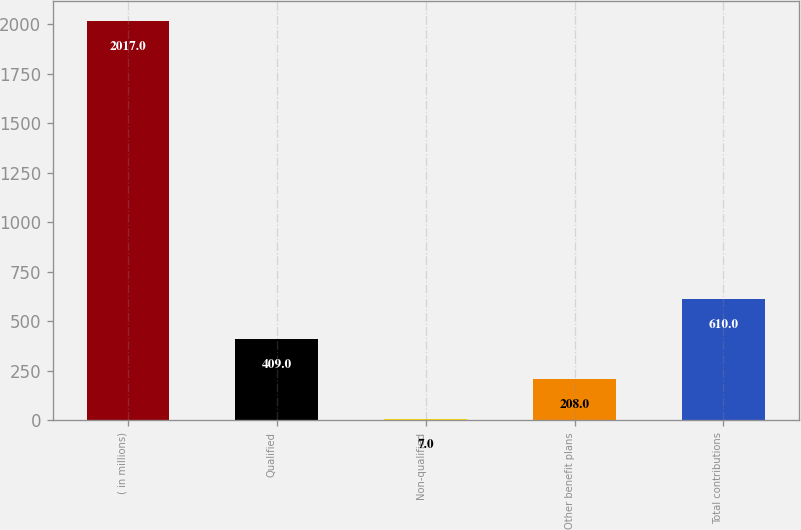Convert chart. <chart><loc_0><loc_0><loc_500><loc_500><bar_chart><fcel>( in millions)<fcel>Qualified<fcel>Non-qualified<fcel>Other benefit plans<fcel>Total contributions<nl><fcel>2017<fcel>409<fcel>7<fcel>208<fcel>610<nl></chart> 